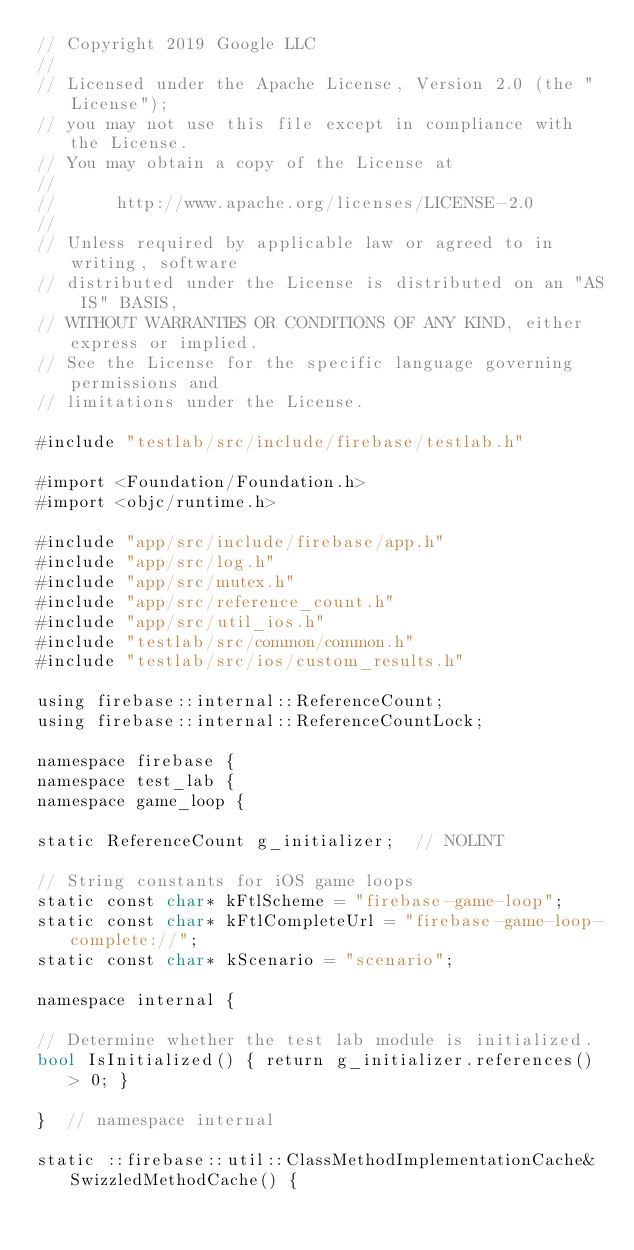<code> <loc_0><loc_0><loc_500><loc_500><_ObjectiveC_>// Copyright 2019 Google LLC
//
// Licensed under the Apache License, Version 2.0 (the "License");
// you may not use this file except in compliance with the License.
// You may obtain a copy of the License at
//
//      http://www.apache.org/licenses/LICENSE-2.0
//
// Unless required by applicable law or agreed to in writing, software
// distributed under the License is distributed on an "AS IS" BASIS,
// WITHOUT WARRANTIES OR CONDITIONS OF ANY KIND, either express or implied.
// See the License for the specific language governing permissions and
// limitations under the License.

#include "testlab/src/include/firebase/testlab.h"

#import <Foundation/Foundation.h>
#import <objc/runtime.h>

#include "app/src/include/firebase/app.h"
#include "app/src/log.h"
#include "app/src/mutex.h"
#include "app/src/reference_count.h"
#include "app/src/util_ios.h"
#include "testlab/src/common/common.h"
#include "testlab/src/ios/custom_results.h"

using firebase::internal::ReferenceCount;
using firebase::internal::ReferenceCountLock;

namespace firebase {
namespace test_lab {
namespace game_loop {

static ReferenceCount g_initializer;  // NOLINT

// String constants for iOS game loops
static const char* kFtlScheme = "firebase-game-loop";
static const char* kFtlCompleteUrl = "firebase-game-loop-complete://";
static const char* kScenario = "scenario";

namespace internal {

// Determine whether the test lab module is initialized.
bool IsInitialized() { return g_initializer.references() > 0; }

}  // namespace internal

static ::firebase::util::ClassMethodImplementationCache& SwizzledMethodCache() {</code> 